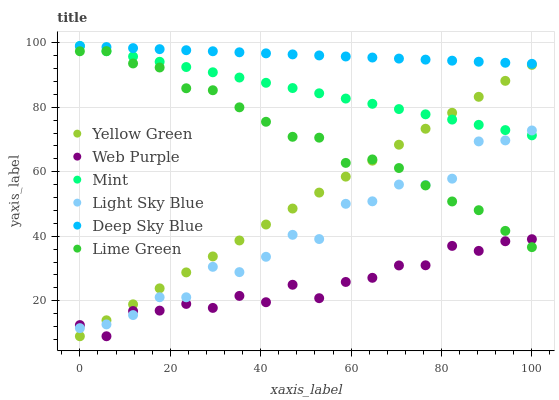Does Web Purple have the minimum area under the curve?
Answer yes or no. Yes. Does Deep Sky Blue have the maximum area under the curve?
Answer yes or no. Yes. Does Mint have the minimum area under the curve?
Answer yes or no. No. Does Mint have the maximum area under the curve?
Answer yes or no. No. Is Yellow Green the smoothest?
Answer yes or no. Yes. Is Light Sky Blue the roughest?
Answer yes or no. Yes. Is Mint the smoothest?
Answer yes or no. No. Is Mint the roughest?
Answer yes or no. No. Does Yellow Green have the lowest value?
Answer yes or no. Yes. Does Mint have the lowest value?
Answer yes or no. No. Does Deep Sky Blue have the highest value?
Answer yes or no. Yes. Does Web Purple have the highest value?
Answer yes or no. No. Is Web Purple less than Mint?
Answer yes or no. Yes. Is Deep Sky Blue greater than Yellow Green?
Answer yes or no. Yes. Does Light Sky Blue intersect Mint?
Answer yes or no. Yes. Is Light Sky Blue less than Mint?
Answer yes or no. No. Is Light Sky Blue greater than Mint?
Answer yes or no. No. Does Web Purple intersect Mint?
Answer yes or no. No. 